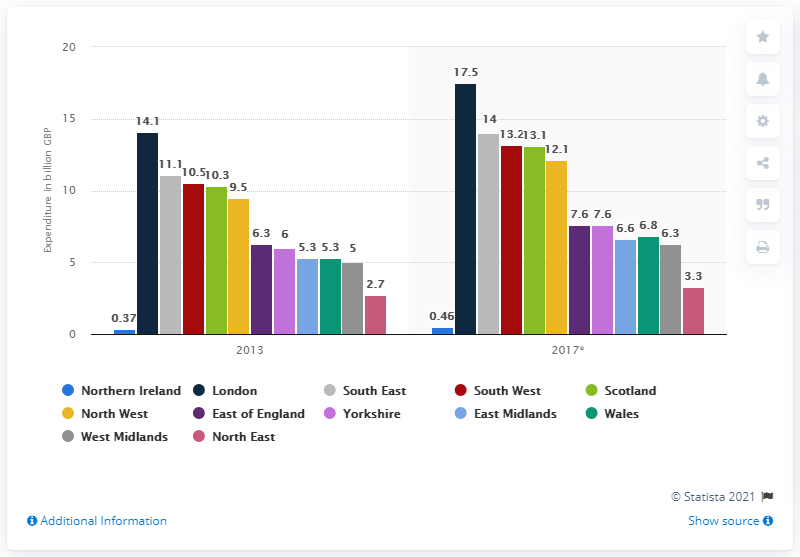Specify some key components in this picture. In 2013, the amount of money spent on domestic travel in London was 14.. In 2013, London's domestic travel spending was 17.5... In 2013, domestic tourist spending increased in various regions of the United Kingdom. 